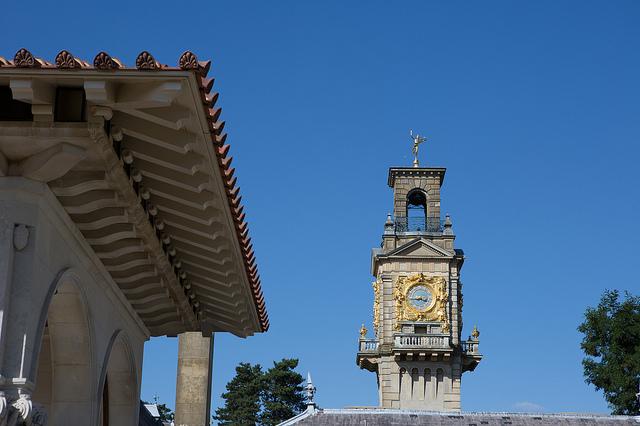How many arches are there in the scene?
Give a very brief answer. 3. What type of roof is on the building?
Give a very brief answer. Tile. How is the sky?
Concise answer only. Clear. What is the weather in this photo?
Answer briefly. Sunny. 